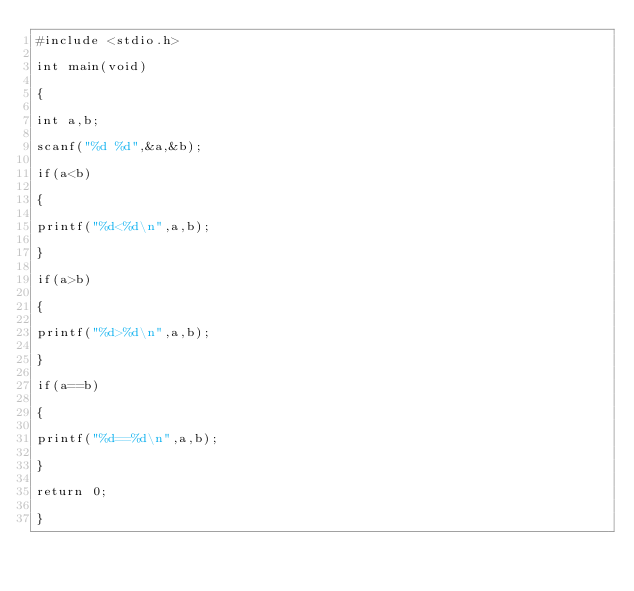Convert code to text. <code><loc_0><loc_0><loc_500><loc_500><_C_>#include <stdio.h>

int main(void)

{

int a,b;

scanf("%d %d",&a,&b);

if(a<b)

{

printf("%d<%d\n",a,b);

}

if(a>b)

{

printf("%d>%d\n",a,b);

}

if(a==b)

{

printf("%d==%d\n",a,b);

}

return 0;

}</code> 